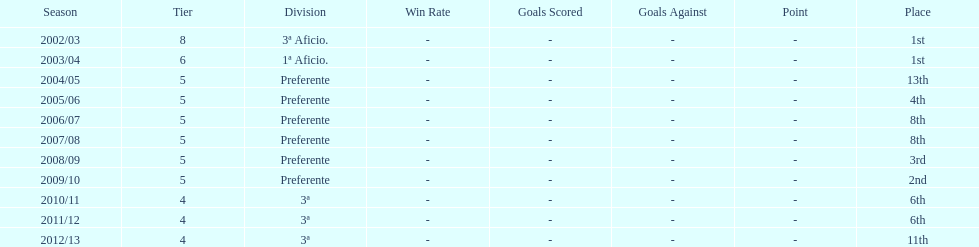How many seasons did internacional de madrid cf play in the preferente division? 6. 